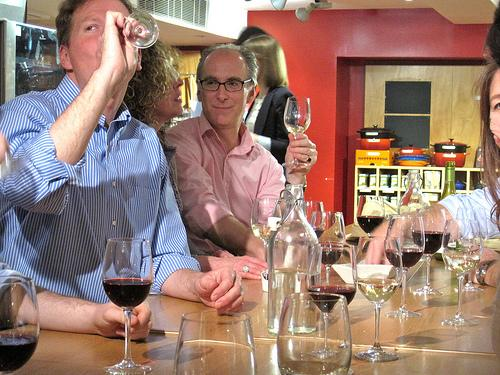Count the number of wine glasses in the image. There are at least four wine glasses in the image. What is the color and pattern of the shirt worn by the man listening to the woman talk? The shirt is blue and white striped. In a single sentence, describe the table setting in the image. The table setting includes wine glasses filled with red wine, a glass bottle at the center, and possibly a white dish filled with food. How would you describe the emotional atmosphere of the image? The sentiment of the image seems relaxed and casual, as people are enjoying wine and conversation. Describe the physical appearance of the man drinking red wine. The man is bald, wearing eyeglasses, and dressed in a pink shirt. Name the object that is found in the man's hand. The man is holding a glass. Determine the action the woman in the image is performing. The woman is reaching for food in a white dish. Identify the hairstyle of the woman in the image. The woman has curly short blonde hair. Identify an object that is partially visible or cropped in the image. Part of a table is partly visible at the edge of the image. List two accessories worn by the balding man wearing glasses. The balding man is wearing eyeglasses and a pink shirt. Can you find the yellow button on the pink shirt? The image has information about a white button on a blue shirt, but nothing about a yellow button on a pink shirt. Are the black rimmed eye glasses filled with red wine? The image has information about black rimmed eye glasses and wine glasses filled with red wine, but they are separate objects and not combined in this way. Is there a purple cooking pot with a black lid on the shelf? The image has information about a black lid on a cooking pot and cooking utensils on a shelf, but it does not combine these two objects and does not mention a purple cooking pot at all. Is the man with curly short blond hair holding a silver ring? The image has information about a man with balding head and a woman with curly short blond hair, and a silver ring on a finger, but it does not mention the man with curly short blond hair holding a silver ring. Can you see the green wine in the clear wine glass? The image has information about red wine in a glass, but nothing about green wine. Is the green shirt the woman is wearing part of the table setting? The image does not have information about a woman wearing a green shirt; the only shirts mentioned are blue, white, and pink. 